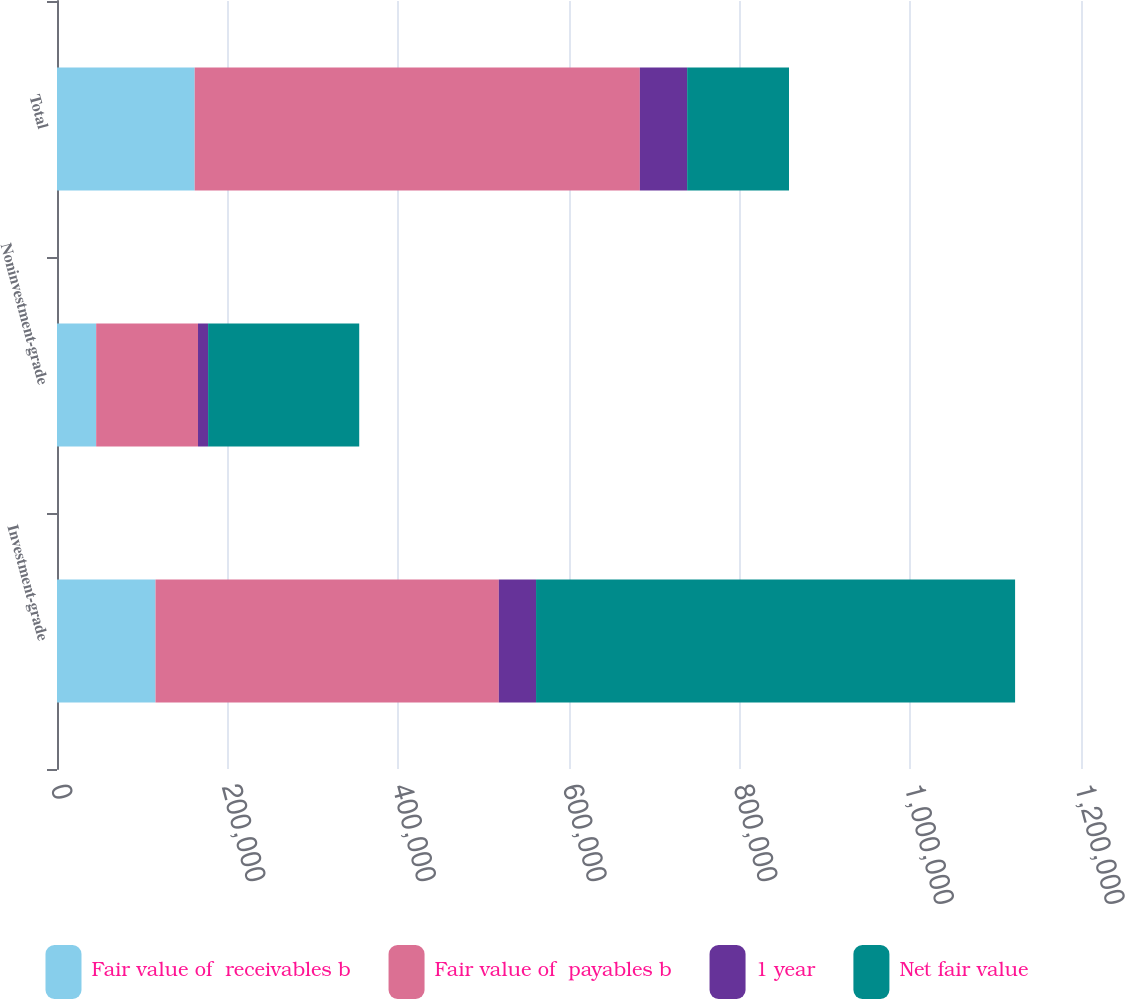Convert chart to OTSL. <chart><loc_0><loc_0><loc_500><loc_500><stacked_bar_chart><ecel><fcel>Investment-grade<fcel>Noninvestment-grade<fcel>Total<nl><fcel>Fair value of  receivables b<fcel>115443<fcel>45897<fcel>161340<nl><fcel>Fair value of  payables b<fcel>402325<fcel>119348<fcel>521673<nl><fcel>1 year<fcel>43611<fcel>11840<fcel>55451<nl><fcel>Net fair value<fcel>561379<fcel>177085<fcel>119348<nl></chart> 